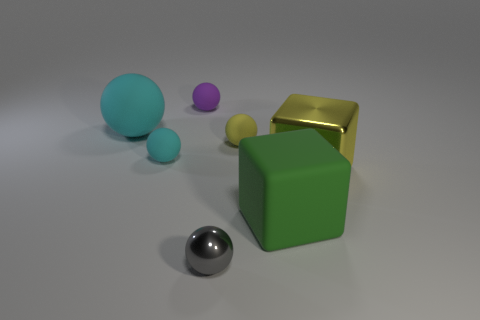What number of cylinders are either small purple things or gray objects?
Provide a short and direct response. 0. Is the material of the small object that is behind the large sphere the same as the yellow cube?
Your response must be concise. No. How many other things are the same size as the yellow rubber sphere?
Offer a very short reply. 3. What number of large objects are either yellow matte balls or cubes?
Make the answer very short. 2. Does the large shiny object have the same color as the tiny metallic ball?
Make the answer very short. No. Is the number of yellow objects that are in front of the small yellow matte thing greater than the number of large matte things right of the big green cube?
Offer a terse response. Yes. Does the small matte object behind the large cyan thing have the same color as the big matte sphere?
Make the answer very short. No. Is there anything else of the same color as the large metallic thing?
Provide a succinct answer. Yes. Is the number of metallic balls that are behind the tiny metal sphere greater than the number of small gray spheres?
Your response must be concise. No. Is the green matte block the same size as the gray ball?
Offer a very short reply. No. 